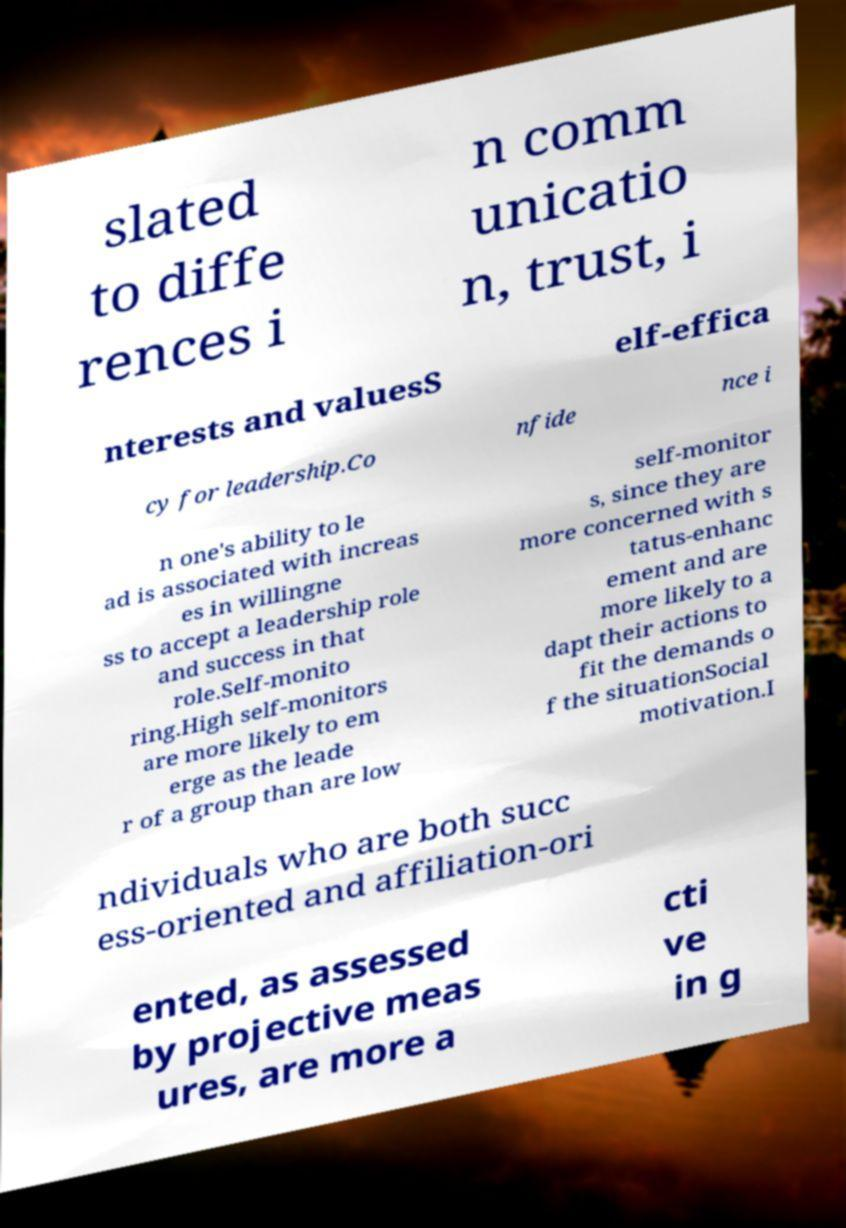Could you assist in decoding the text presented in this image and type it out clearly? slated to diffe rences i n comm unicatio n, trust, i nterests and valuesS elf-effica cy for leadership.Co nfide nce i n one's ability to le ad is associated with increas es in willingne ss to accept a leadership role and success in that role.Self-monito ring.High self-monitors are more likely to em erge as the leade r of a group than are low self-monitor s, since they are more concerned with s tatus-enhanc ement and are more likely to a dapt their actions to fit the demands o f the situationSocial motivation.I ndividuals who are both succ ess-oriented and affiliation-ori ented, as assessed by projective meas ures, are more a cti ve in g 